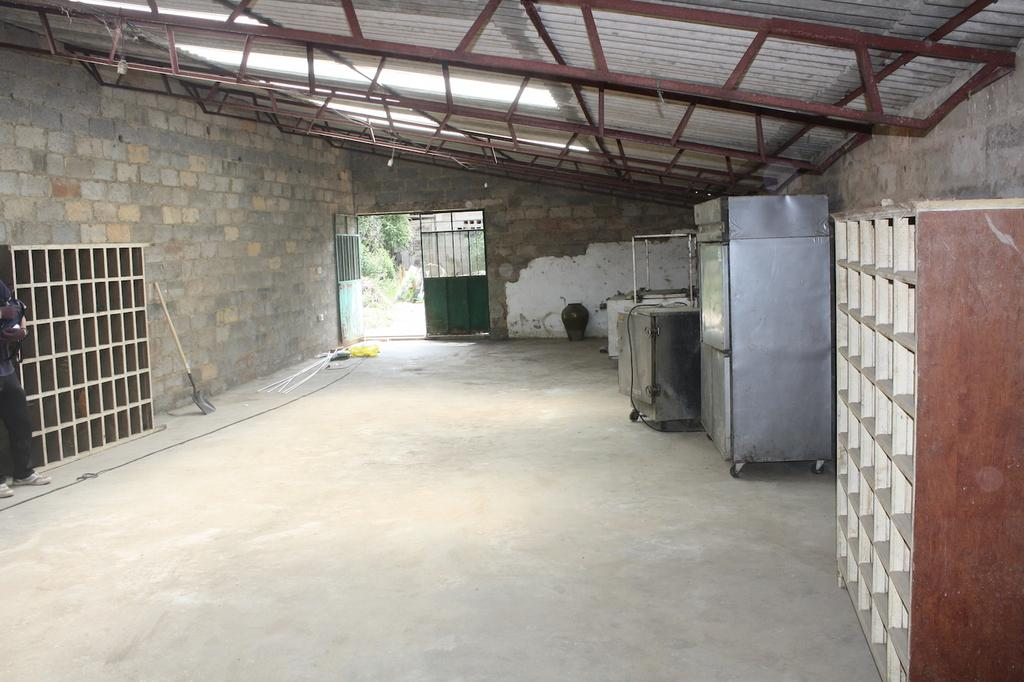What type of furniture is present in the image? There are cupboards in the image. What else can be seen in the image besides the cupboards? There are boxes and objects on the floor in the image. What is the background of the image like? There is a wall, a door, trees, and buildings visible in the image. Can you describe the location where the image might have been taken? The image may have been taken in a hall, as suggested by the presence of cupboards and boxes. What type of coal is being used to bake the loaf of bread in the image? There is no coal or loaf of bread present in the image. What reward is given to the person who cleans the boxes in the image? There is no reward or indication of cleaning the boxes in the image. 